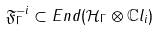<formula> <loc_0><loc_0><loc_500><loc_500>\mathfrak { F } _ { \Gamma } ^ { - i } \subset E n d ( \mathcal { H } _ { \Gamma } \otimes \mathbb { C } l _ { i } )</formula> 